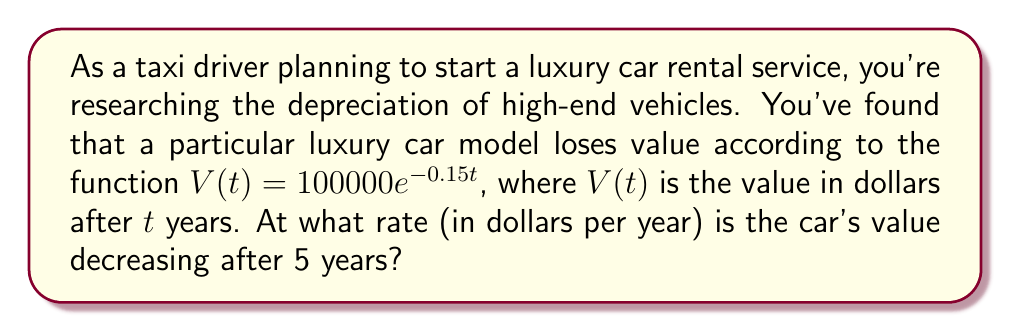Can you solve this math problem? To solve this problem, we need to use calculus to find the rate of change of the car's value after 5 years. Here's a step-by-step approach:

1) The given function for the car's value is:
   $V(t) = 100000e^{-0.15t}$

2) To find the rate of change, we need to differentiate this function with respect to t:
   $$\frac{dV}{dt} = 100000 \cdot (-0.15) \cdot e^{-0.15t}$$
   $$\frac{dV}{dt} = -15000e^{-0.15t}$$

3) This derivative gives us the instantaneous rate of change of the car's value at any time t.

4) We're asked about the rate after 5 years, so we need to evaluate this at t = 5:
   $$\frac{dV}{dt}\bigg|_{t=5} = -15000e^{-0.15(5)}$$
   $$= -15000e^{-0.75}$$

5) Now, let's calculate this value:
   $$-15000 \cdot e^{-0.75} \approx -7126.47$$

6) The negative sign indicates that the value is decreasing.

Therefore, after 5 years, the car's value is decreasing at a rate of approximately $7,126.47 per year.
Answer: $7,126.47 per year 